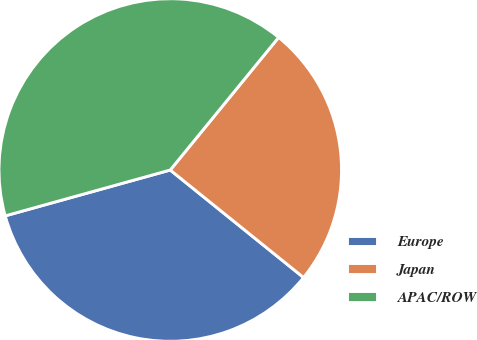Convert chart to OTSL. <chart><loc_0><loc_0><loc_500><loc_500><pie_chart><fcel>Europe<fcel>Japan<fcel>APAC/ROW<nl><fcel>34.89%<fcel>24.9%<fcel>40.22%<nl></chart> 